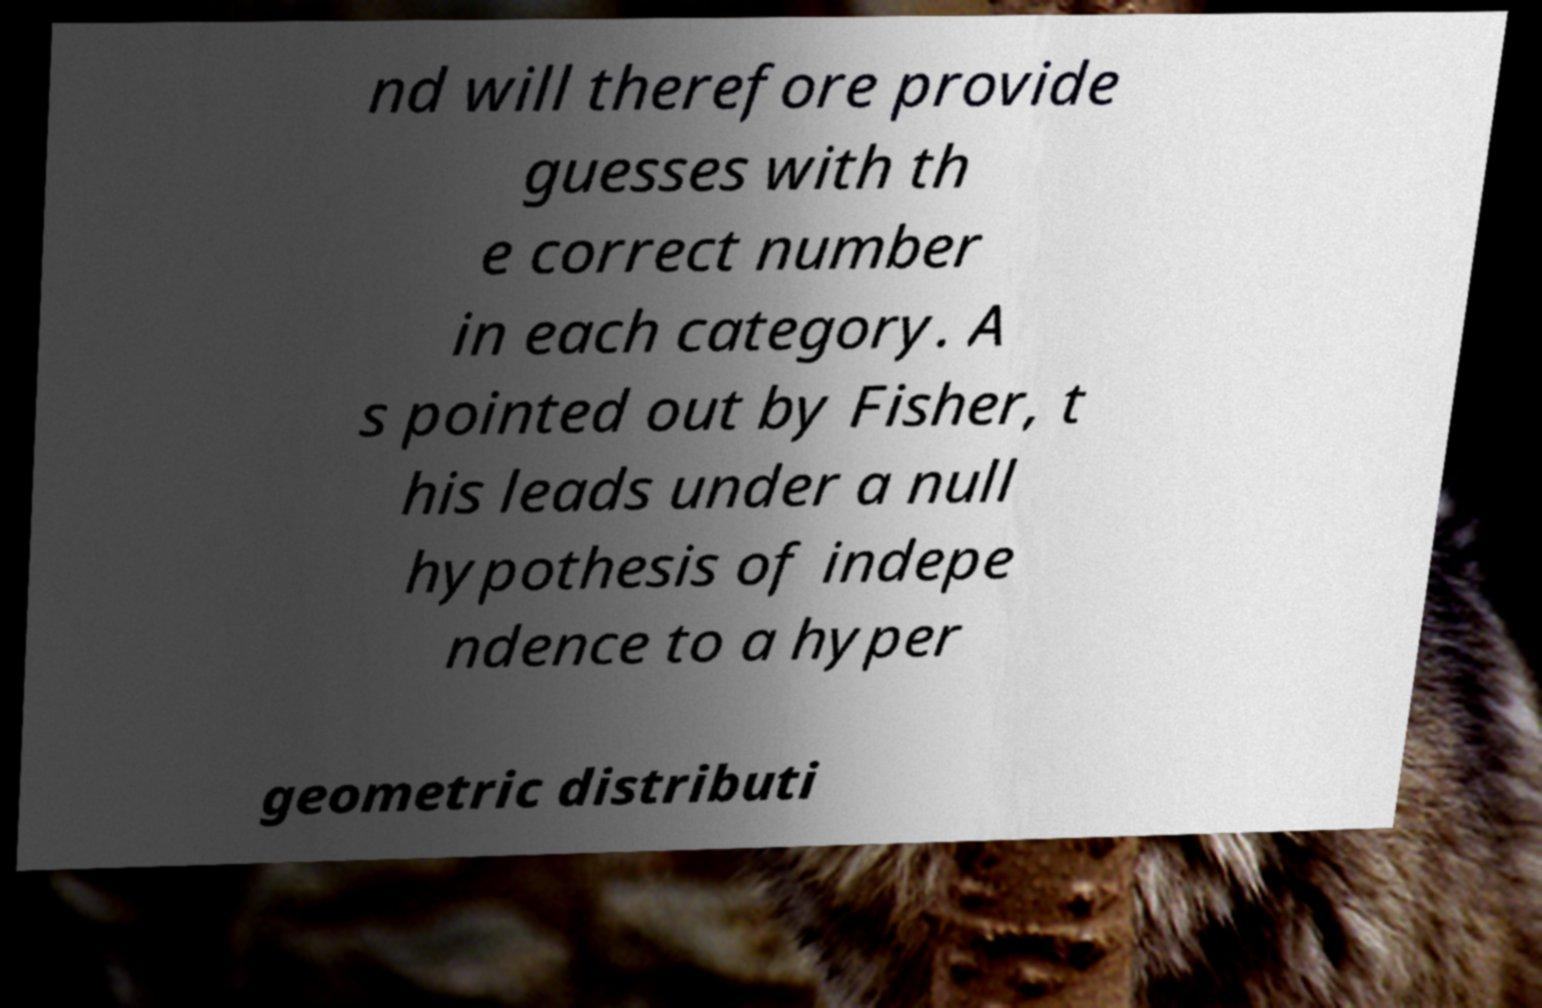Please read and relay the text visible in this image. What does it say? nd will therefore provide guesses with th e correct number in each category. A s pointed out by Fisher, t his leads under a null hypothesis of indepe ndence to a hyper geometric distributi 